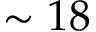<formula> <loc_0><loc_0><loc_500><loc_500>\sim 1 8</formula> 